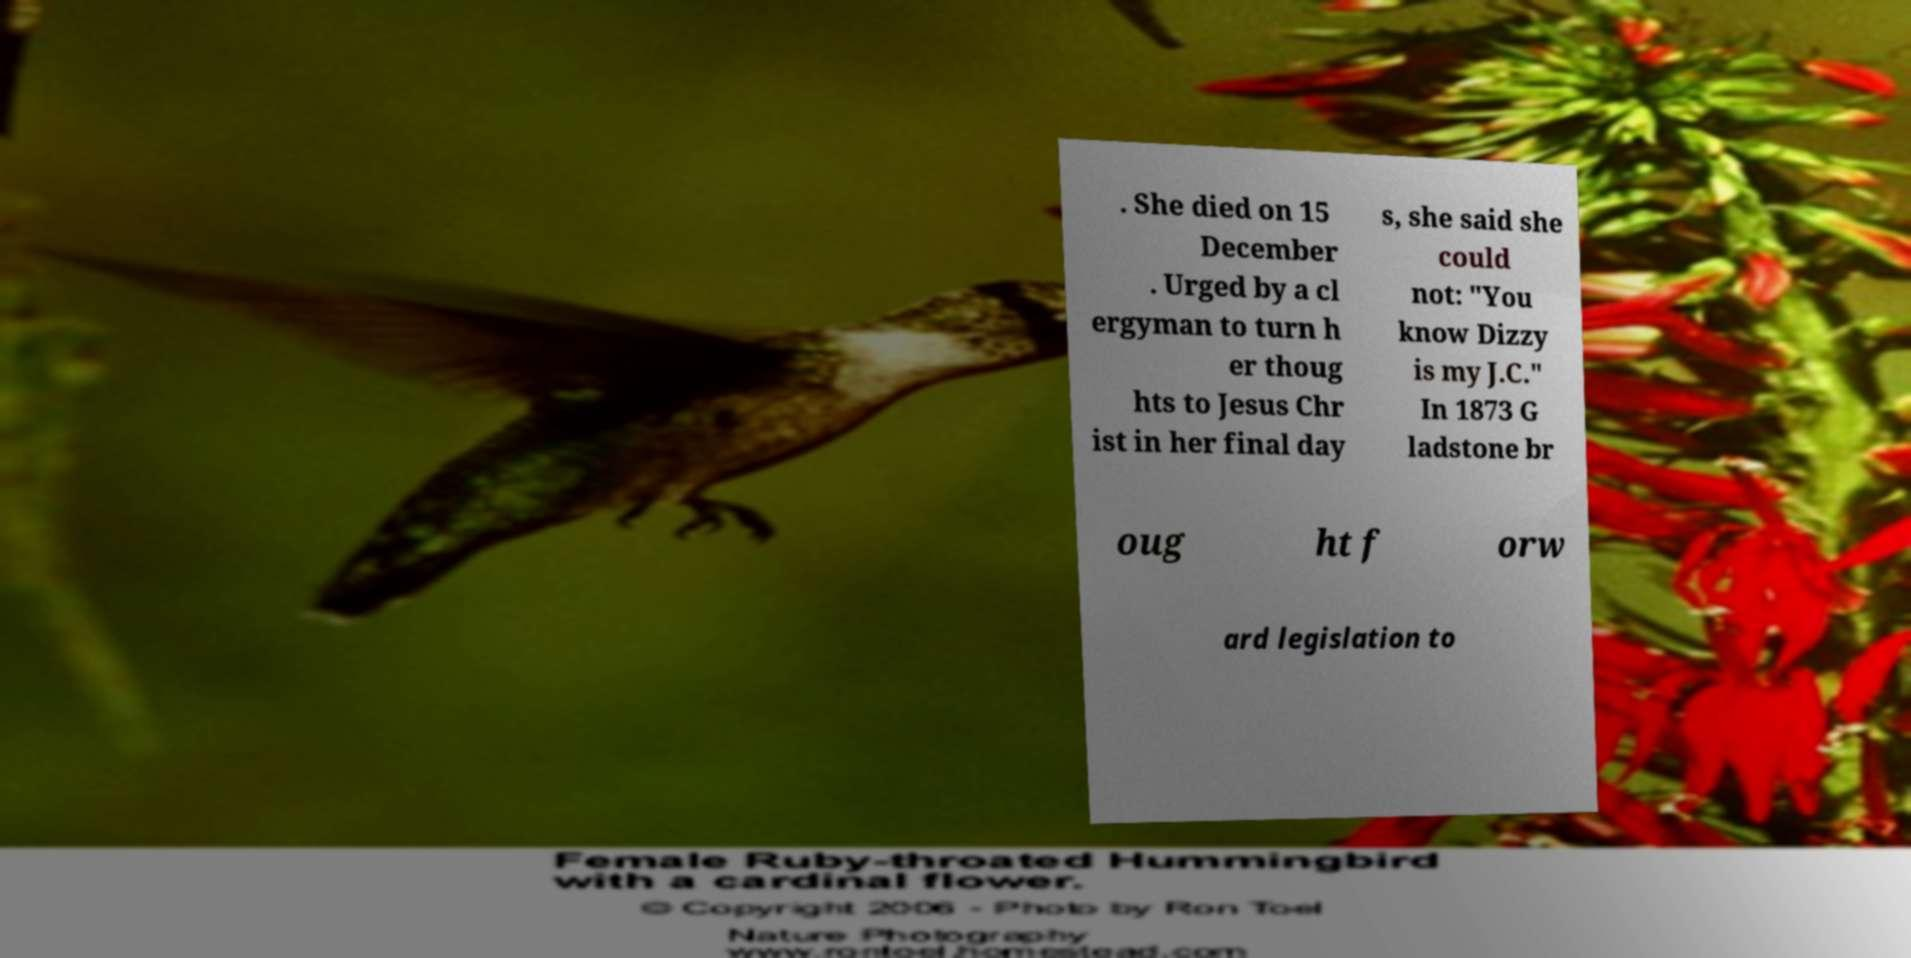I need the written content from this picture converted into text. Can you do that? . She died on 15 December . Urged by a cl ergyman to turn h er thoug hts to Jesus Chr ist in her final day s, she said she could not: "You know Dizzy is my J.C." In 1873 G ladstone br oug ht f orw ard legislation to 